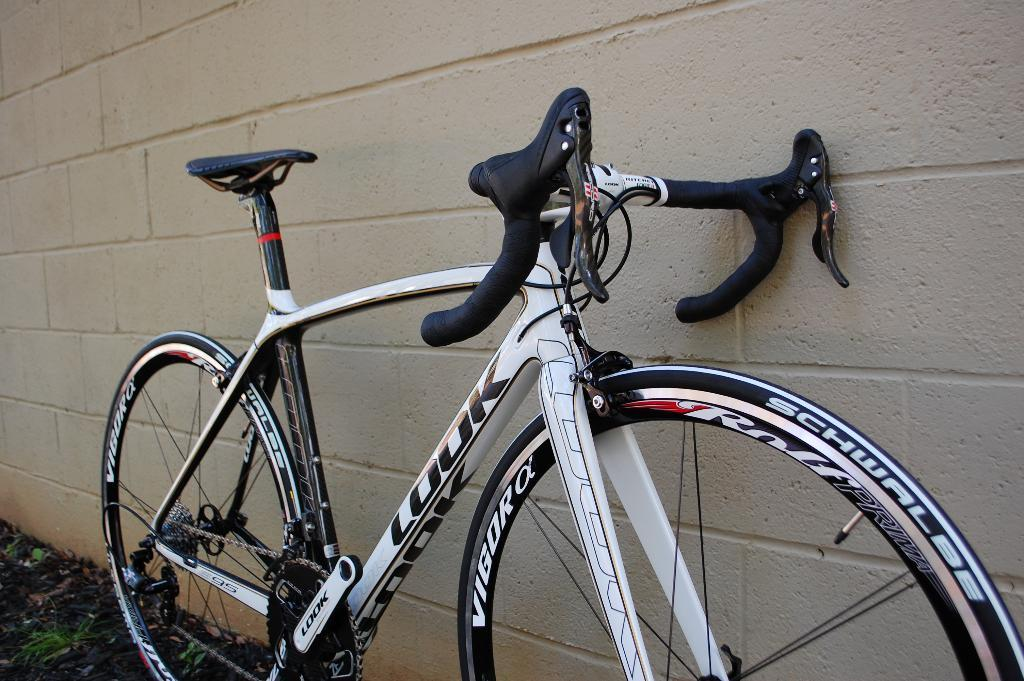What is the main object in the image? There is a bicycle in the image. Where is the bicycle located in relation to other objects or structures? The bicycle is placed beside a wall. What type of chicken can be seen sitting on the handlebars of the bicycle in the image? There is no chicken present in the image, and the bicycle does not have any handlebars. 